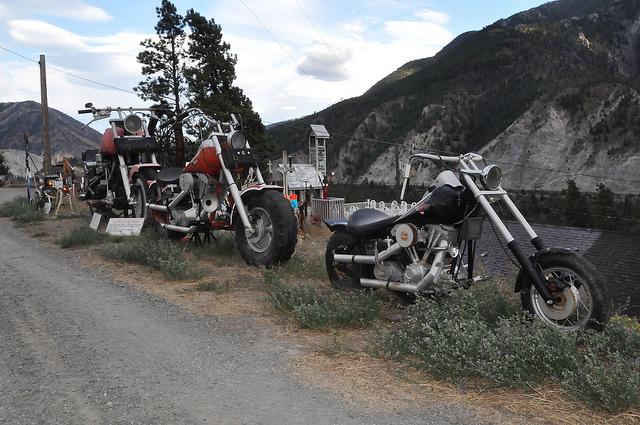Are people riding the bikes?
Give a very brief answer. No. Is it overcast?
Be succinct. No. Which motorcycle has the bigger tire?
Concise answer only. 2nd. What main color is the bike in the front?
Answer briefly. Black. 